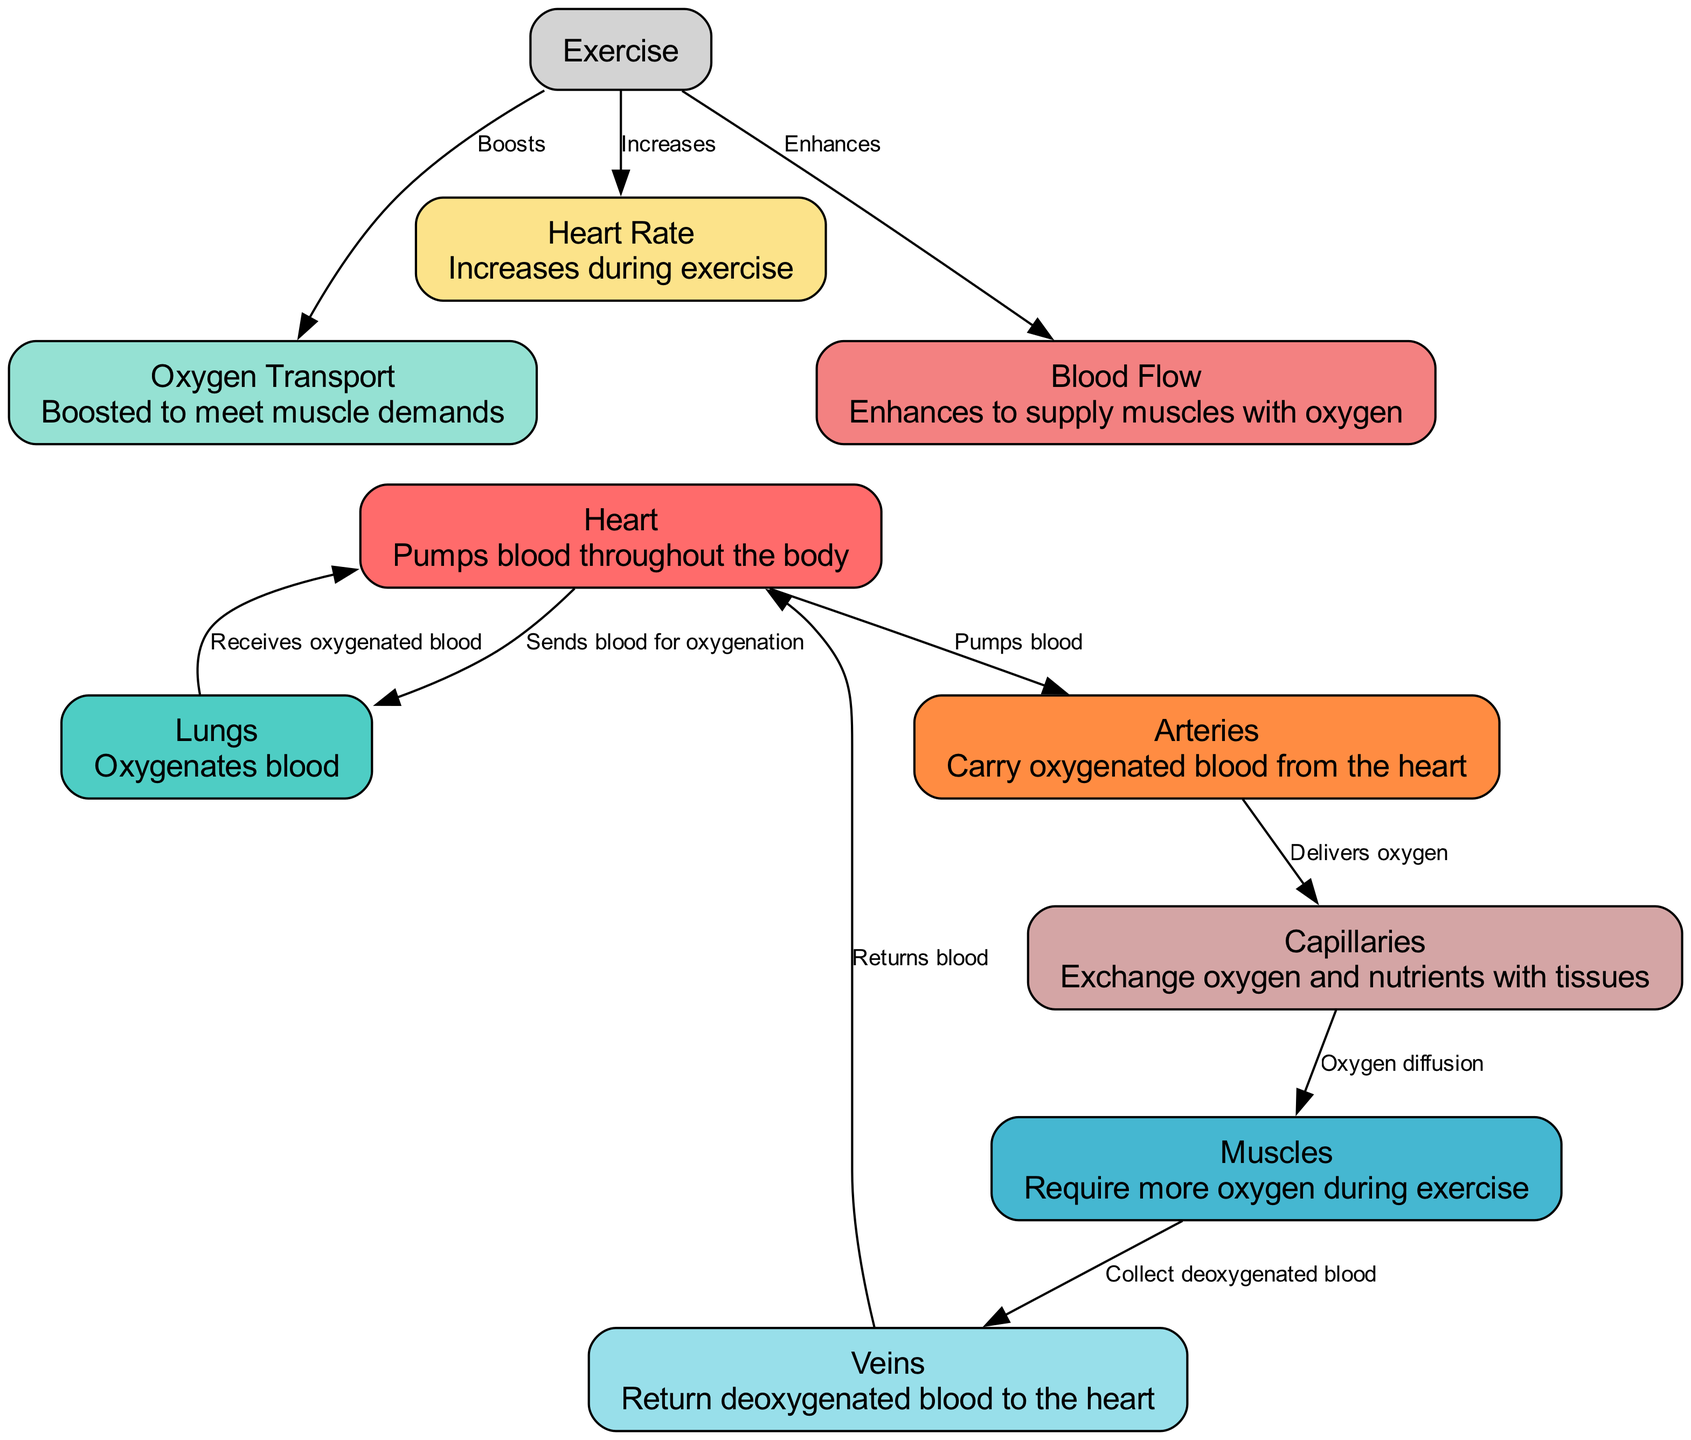What is the main function of the Heart node? The Heart node is described as "Pumps blood throughout the body." This directly reflects its primary role in the cardiovascular system.
Answer: Pumps blood throughout the body How many total nodes are in the diagram? By counting all the unique entities represented in the diagram, we see there are 9 nodes: Heart, Lungs, Muscles, Arteries, Veins, Capillaries, Heart Rate, Blood Flow, and Oxygen Transport.
Answer: 9 What connects the Arteries to the Capillaries? The edge labeled "Delivers oxygen" connects the Arteries to the Capillaries, indicating the function of the arteries in the oxygen delivery process.
Answer: Delivers oxygen How does Exercise affect Heart Rate? The edge connecting Exercise to Heart Rate is labeled "Increases," indicating that physical activity elevates heart rate during exercise.
Answer: Increases Which node receives oxygenated blood from the Lungs? The edge between Lungs and Heart is labeled "Receives oxygenated blood," showing that the Heart is the recipient of oxygenated blood that returns from the Lungs.
Answer: Heart What is the role of Capillaries in this diagram? The description for Capillaries states: "Exchange oxygen and nutrients with tissues." This highlights their function in delivering essential substances to body tissues.
Answer: Exchange oxygen and nutrients with tissues What happens to Blood Flow during exercise? The edge connecting Exercise to Blood Flow is labeled "Enhances," which indicates that blood flow is increased to better meet the demands placed on the cardiovascular system during physical activity.
Answer: Enhances How does Oxygen Transport change during exercise? The edge labeled "Boosts" from Exercise to Oxygen Transport illustrates that physical activity significantly increases the efficiency and ability of oxygen transport to muscles.
Answer: Boosts What happens to deoxygenated blood collected from Muscles? The edge from Muscles to Veins states "Collect deoxygenated blood," meaning that the veins gather the blood that has delivered oxygen to the muscles and is now lacking it.
Answer: Collect deoxygenated blood 